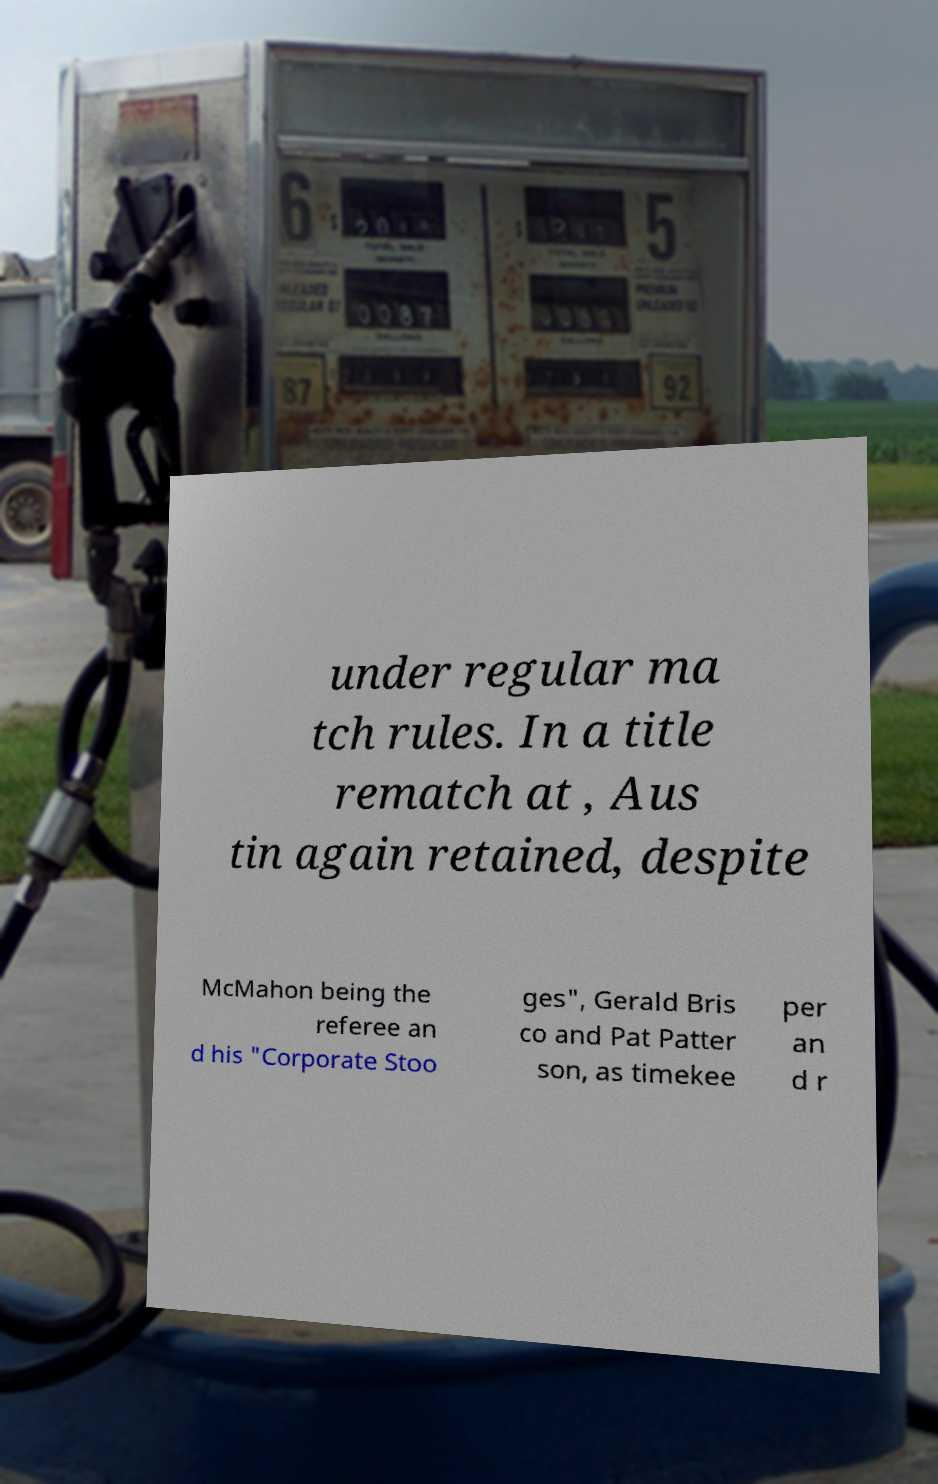Can you accurately transcribe the text from the provided image for me? under regular ma tch rules. In a title rematch at , Aus tin again retained, despite McMahon being the referee an d his "Corporate Stoo ges", Gerald Bris co and Pat Patter son, as timekee per an d r 